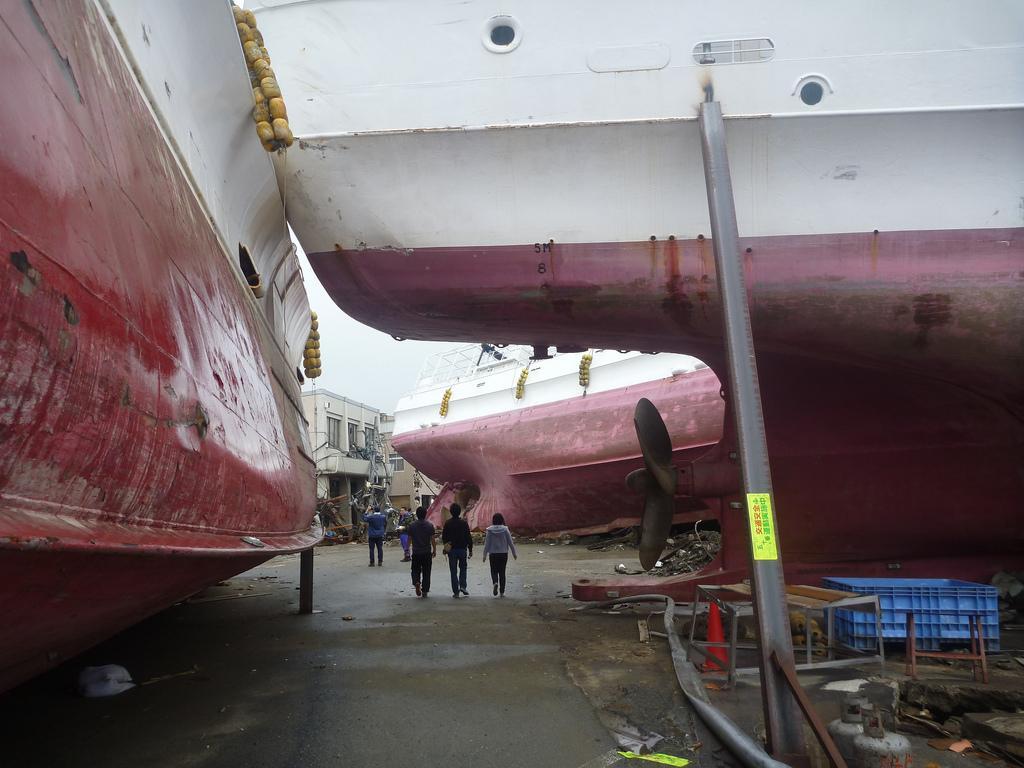Can you describe this image briefly? In this image we can see ships which are in pink and white color. Behind building is there. Right side of the image some pillar and container is present. On the road people are walking. 